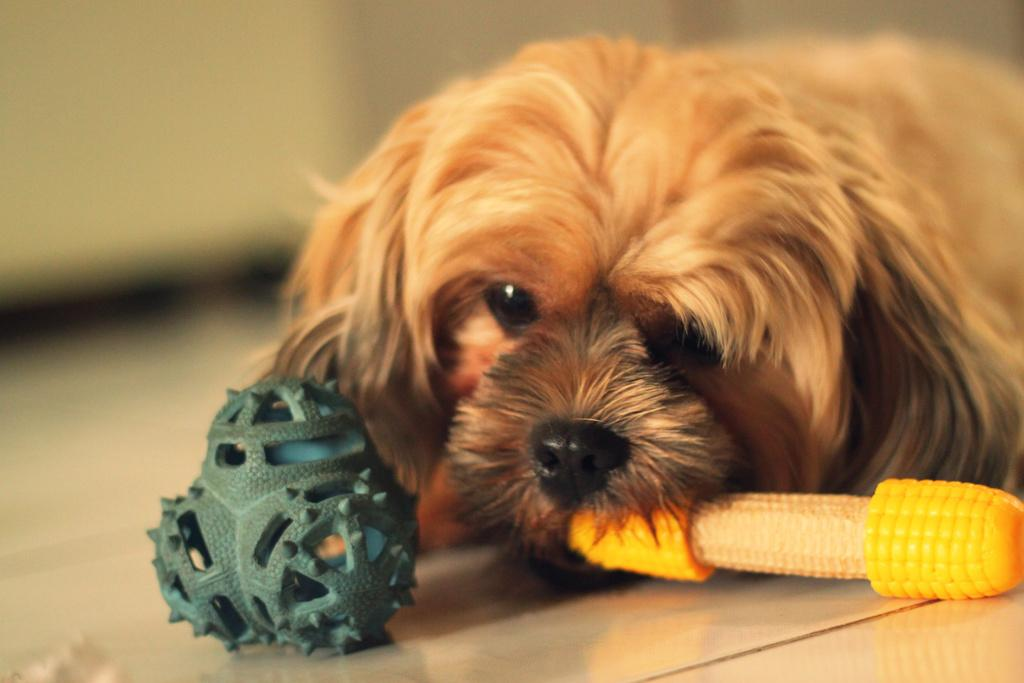What type of animal is in the image? There is a brown dog in the image. What type of plants are in the image? There are corn plants in the image. Can you describe the background of the image? The background of the image is blurred. How many questions are being asked in the image? There are no questions visible in the image; it features a brown dog and corn plants. Is there any dust present in the image? There is no mention of dust in the image, and it cannot be determined from the provided facts. 